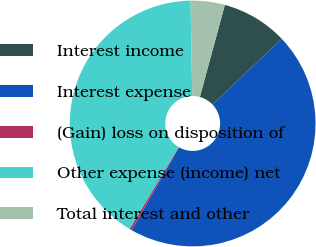Convert chart. <chart><loc_0><loc_0><loc_500><loc_500><pie_chart><fcel>Interest income<fcel>Interest expense<fcel>(Gain) loss on disposition of<fcel>Other expense (income) net<fcel>Total interest and other<nl><fcel>8.69%<fcel>45.36%<fcel>0.3%<fcel>41.16%<fcel>4.49%<nl></chart> 